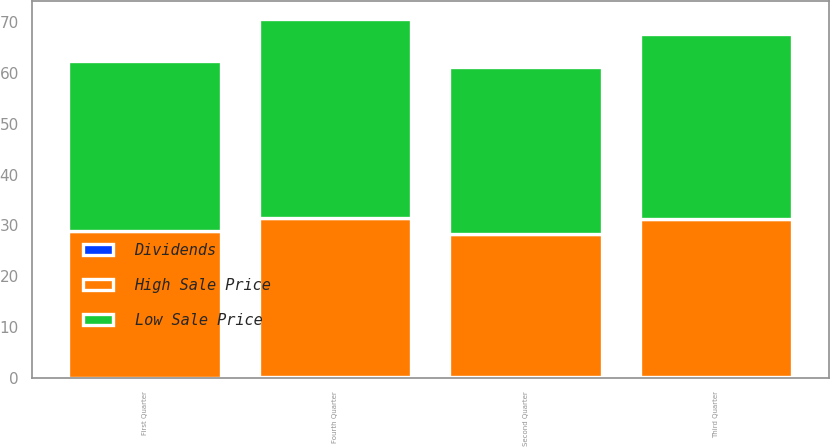<chart> <loc_0><loc_0><loc_500><loc_500><stacked_bar_chart><ecel><fcel>Fourth Quarter<fcel>Third Quarter<fcel>Second Quarter<fcel>First Quarter<nl><fcel>High Sale Price<fcel>31.35<fcel>31.12<fcel>28.31<fcel>28.78<nl><fcel>Low Sale Price<fcel>39.19<fcel>36.44<fcel>32.82<fcel>33.52<nl><fcel>Dividends<fcel>0.1<fcel>0.1<fcel>0.1<fcel>0.05<nl></chart> 